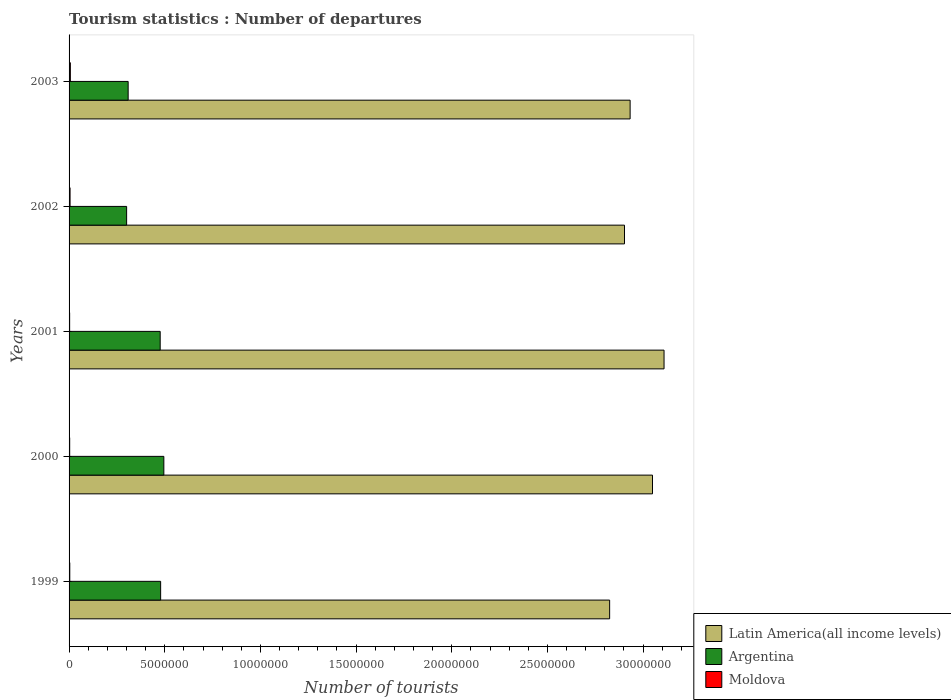Are the number of bars on each tick of the Y-axis equal?
Your answer should be very brief. Yes. How many bars are there on the 2nd tick from the top?
Ensure brevity in your answer.  3. What is the label of the 4th group of bars from the top?
Ensure brevity in your answer.  2000. What is the number of tourist departures in Latin America(all income levels) in 1999?
Give a very brief answer. 2.83e+07. Across all years, what is the maximum number of tourist departures in Moldova?
Ensure brevity in your answer.  6.70e+04. Across all years, what is the minimum number of tourist departures in Moldova?
Your answer should be very brief. 3.00e+04. In which year was the number of tourist departures in Moldova minimum?
Ensure brevity in your answer.  2001. What is the total number of tourist departures in Argentina in the graph?
Make the answer very short. 2.06e+07. What is the difference between the number of tourist departures in Argentina in 2002 and that in 2003?
Your answer should be very brief. -8.00e+04. What is the difference between the number of tourist departures in Argentina in 2000 and the number of tourist departures in Latin America(all income levels) in 2002?
Make the answer very short. -2.41e+07. What is the average number of tourist departures in Argentina per year?
Give a very brief answer. 4.12e+06. In the year 1999, what is the difference between the number of tourist departures in Argentina and number of tourist departures in Moldova?
Give a very brief answer. 4.75e+06. What is the ratio of the number of tourist departures in Argentina in 2001 to that in 2002?
Your answer should be very brief. 1.58. Is the number of tourist departures in Moldova in 1999 less than that in 2002?
Ensure brevity in your answer.  Yes. What is the difference between the highest and the second highest number of tourist departures in Latin America(all income levels)?
Your response must be concise. 6.03e+05. What is the difference between the highest and the lowest number of tourist departures in Moldova?
Ensure brevity in your answer.  3.70e+04. Is the sum of the number of tourist departures in Argentina in 2001 and 2002 greater than the maximum number of tourist departures in Latin America(all income levels) across all years?
Your response must be concise. No. What does the 3rd bar from the top in 2000 represents?
Make the answer very short. Latin America(all income levels). What does the 3rd bar from the bottom in 2001 represents?
Offer a terse response. Moldova. How many bars are there?
Provide a short and direct response. 15. Are all the bars in the graph horizontal?
Offer a very short reply. Yes. Are the values on the major ticks of X-axis written in scientific E-notation?
Offer a very short reply. No. Does the graph contain any zero values?
Keep it short and to the point. No. Does the graph contain grids?
Give a very brief answer. No. Where does the legend appear in the graph?
Offer a terse response. Bottom right. How many legend labels are there?
Make the answer very short. 3. How are the legend labels stacked?
Ensure brevity in your answer.  Vertical. What is the title of the graph?
Offer a very short reply. Tourism statistics : Number of departures. What is the label or title of the X-axis?
Ensure brevity in your answer.  Number of tourists. What is the Number of tourists in Latin America(all income levels) in 1999?
Your answer should be very brief. 2.83e+07. What is the Number of tourists of Argentina in 1999?
Your answer should be very brief. 4.79e+06. What is the Number of tourists in Moldova in 1999?
Your response must be concise. 3.70e+04. What is the Number of tourists of Latin America(all income levels) in 2000?
Give a very brief answer. 3.05e+07. What is the Number of tourists of Argentina in 2000?
Offer a very short reply. 4.95e+06. What is the Number of tourists in Moldova in 2000?
Your answer should be very brief. 3.20e+04. What is the Number of tourists of Latin America(all income levels) in 2001?
Provide a succinct answer. 3.11e+07. What is the Number of tourists of Argentina in 2001?
Provide a succinct answer. 4.76e+06. What is the Number of tourists of Moldova in 2001?
Offer a terse response. 3.00e+04. What is the Number of tourists of Latin America(all income levels) in 2002?
Your response must be concise. 2.90e+07. What is the Number of tourists of Argentina in 2002?
Ensure brevity in your answer.  3.01e+06. What is the Number of tourists of Moldova in 2002?
Your response must be concise. 5.20e+04. What is the Number of tourists of Latin America(all income levels) in 2003?
Keep it short and to the point. 2.93e+07. What is the Number of tourists in Argentina in 2003?
Keep it short and to the point. 3.09e+06. What is the Number of tourists in Moldova in 2003?
Offer a terse response. 6.70e+04. Across all years, what is the maximum Number of tourists in Latin America(all income levels)?
Make the answer very short. 3.11e+07. Across all years, what is the maximum Number of tourists in Argentina?
Your response must be concise. 4.95e+06. Across all years, what is the maximum Number of tourists of Moldova?
Keep it short and to the point. 6.70e+04. Across all years, what is the minimum Number of tourists of Latin America(all income levels)?
Make the answer very short. 2.83e+07. Across all years, what is the minimum Number of tourists of Argentina?
Provide a succinct answer. 3.01e+06. Across all years, what is the minimum Number of tourists in Moldova?
Ensure brevity in your answer.  3.00e+04. What is the total Number of tourists in Latin America(all income levels) in the graph?
Offer a very short reply. 1.48e+08. What is the total Number of tourists in Argentina in the graph?
Give a very brief answer. 2.06e+07. What is the total Number of tourists of Moldova in the graph?
Your answer should be very brief. 2.18e+05. What is the difference between the Number of tourists of Latin America(all income levels) in 1999 and that in 2000?
Your answer should be very brief. -2.24e+06. What is the difference between the Number of tourists of Argentina in 1999 and that in 2000?
Offer a terse response. -1.67e+05. What is the difference between the Number of tourists in Latin America(all income levels) in 1999 and that in 2001?
Make the answer very short. -2.84e+06. What is the difference between the Number of tourists of Argentina in 1999 and that in 2001?
Offer a very short reply. 2.40e+04. What is the difference between the Number of tourists of Moldova in 1999 and that in 2001?
Offer a terse response. 7000. What is the difference between the Number of tourists of Latin America(all income levels) in 1999 and that in 2002?
Your response must be concise. -7.77e+05. What is the difference between the Number of tourists in Argentina in 1999 and that in 2002?
Your answer should be compact. 1.78e+06. What is the difference between the Number of tourists of Moldova in 1999 and that in 2002?
Ensure brevity in your answer.  -1.50e+04. What is the difference between the Number of tourists of Latin America(all income levels) in 1999 and that in 2003?
Provide a short and direct response. -1.07e+06. What is the difference between the Number of tourists of Argentina in 1999 and that in 2003?
Keep it short and to the point. 1.70e+06. What is the difference between the Number of tourists in Moldova in 1999 and that in 2003?
Keep it short and to the point. -3.00e+04. What is the difference between the Number of tourists in Latin America(all income levels) in 2000 and that in 2001?
Offer a very short reply. -6.03e+05. What is the difference between the Number of tourists of Argentina in 2000 and that in 2001?
Offer a terse response. 1.91e+05. What is the difference between the Number of tourists of Latin America(all income levels) in 2000 and that in 2002?
Offer a very short reply. 1.46e+06. What is the difference between the Number of tourists of Argentina in 2000 and that in 2002?
Offer a very short reply. 1.94e+06. What is the difference between the Number of tourists of Latin America(all income levels) in 2000 and that in 2003?
Offer a very short reply. 1.17e+06. What is the difference between the Number of tourists in Argentina in 2000 and that in 2003?
Provide a short and direct response. 1.86e+06. What is the difference between the Number of tourists in Moldova in 2000 and that in 2003?
Your answer should be compact. -3.50e+04. What is the difference between the Number of tourists in Latin America(all income levels) in 2001 and that in 2002?
Offer a very short reply. 2.07e+06. What is the difference between the Number of tourists of Argentina in 2001 and that in 2002?
Ensure brevity in your answer.  1.75e+06. What is the difference between the Number of tourists of Moldova in 2001 and that in 2002?
Offer a terse response. -2.20e+04. What is the difference between the Number of tourists in Latin America(all income levels) in 2001 and that in 2003?
Your answer should be compact. 1.77e+06. What is the difference between the Number of tourists of Argentina in 2001 and that in 2003?
Your answer should be compact. 1.67e+06. What is the difference between the Number of tourists in Moldova in 2001 and that in 2003?
Keep it short and to the point. -3.70e+04. What is the difference between the Number of tourists in Latin America(all income levels) in 2002 and that in 2003?
Your answer should be compact. -2.94e+05. What is the difference between the Number of tourists of Moldova in 2002 and that in 2003?
Your answer should be very brief. -1.50e+04. What is the difference between the Number of tourists in Latin America(all income levels) in 1999 and the Number of tourists in Argentina in 2000?
Ensure brevity in your answer.  2.33e+07. What is the difference between the Number of tourists of Latin America(all income levels) in 1999 and the Number of tourists of Moldova in 2000?
Give a very brief answer. 2.82e+07. What is the difference between the Number of tourists of Argentina in 1999 and the Number of tourists of Moldova in 2000?
Provide a succinct answer. 4.75e+06. What is the difference between the Number of tourists of Latin America(all income levels) in 1999 and the Number of tourists of Argentina in 2001?
Offer a very short reply. 2.35e+07. What is the difference between the Number of tourists in Latin America(all income levels) in 1999 and the Number of tourists in Moldova in 2001?
Your answer should be compact. 2.82e+07. What is the difference between the Number of tourists of Argentina in 1999 and the Number of tourists of Moldova in 2001?
Provide a short and direct response. 4.76e+06. What is the difference between the Number of tourists in Latin America(all income levels) in 1999 and the Number of tourists in Argentina in 2002?
Offer a terse response. 2.52e+07. What is the difference between the Number of tourists of Latin America(all income levels) in 1999 and the Number of tourists of Moldova in 2002?
Keep it short and to the point. 2.82e+07. What is the difference between the Number of tourists in Argentina in 1999 and the Number of tourists in Moldova in 2002?
Provide a succinct answer. 4.73e+06. What is the difference between the Number of tourists in Latin America(all income levels) in 1999 and the Number of tourists in Argentina in 2003?
Your response must be concise. 2.52e+07. What is the difference between the Number of tourists in Latin America(all income levels) in 1999 and the Number of tourists in Moldova in 2003?
Make the answer very short. 2.82e+07. What is the difference between the Number of tourists in Argentina in 1999 and the Number of tourists in Moldova in 2003?
Your answer should be very brief. 4.72e+06. What is the difference between the Number of tourists of Latin America(all income levels) in 2000 and the Number of tourists of Argentina in 2001?
Make the answer very short. 2.57e+07. What is the difference between the Number of tourists in Latin America(all income levels) in 2000 and the Number of tourists in Moldova in 2001?
Make the answer very short. 3.05e+07. What is the difference between the Number of tourists of Argentina in 2000 and the Number of tourists of Moldova in 2001?
Your response must be concise. 4.92e+06. What is the difference between the Number of tourists of Latin America(all income levels) in 2000 and the Number of tourists of Argentina in 2002?
Offer a very short reply. 2.75e+07. What is the difference between the Number of tourists of Latin America(all income levels) in 2000 and the Number of tourists of Moldova in 2002?
Ensure brevity in your answer.  3.04e+07. What is the difference between the Number of tourists in Argentina in 2000 and the Number of tourists in Moldova in 2002?
Provide a short and direct response. 4.90e+06. What is the difference between the Number of tourists in Latin America(all income levels) in 2000 and the Number of tourists in Argentina in 2003?
Ensure brevity in your answer.  2.74e+07. What is the difference between the Number of tourists of Latin America(all income levels) in 2000 and the Number of tourists of Moldova in 2003?
Provide a short and direct response. 3.04e+07. What is the difference between the Number of tourists of Argentina in 2000 and the Number of tourists of Moldova in 2003?
Make the answer very short. 4.89e+06. What is the difference between the Number of tourists in Latin America(all income levels) in 2001 and the Number of tourists in Argentina in 2002?
Your answer should be compact. 2.81e+07. What is the difference between the Number of tourists of Latin America(all income levels) in 2001 and the Number of tourists of Moldova in 2002?
Your answer should be very brief. 3.10e+07. What is the difference between the Number of tourists in Argentina in 2001 and the Number of tourists in Moldova in 2002?
Give a very brief answer. 4.71e+06. What is the difference between the Number of tourists of Latin America(all income levels) in 2001 and the Number of tourists of Argentina in 2003?
Offer a terse response. 2.80e+07. What is the difference between the Number of tourists of Latin America(all income levels) in 2001 and the Number of tourists of Moldova in 2003?
Your answer should be very brief. 3.10e+07. What is the difference between the Number of tourists of Argentina in 2001 and the Number of tourists of Moldova in 2003?
Offer a very short reply. 4.70e+06. What is the difference between the Number of tourists of Latin America(all income levels) in 2002 and the Number of tourists of Argentina in 2003?
Your answer should be very brief. 2.59e+07. What is the difference between the Number of tourists of Latin America(all income levels) in 2002 and the Number of tourists of Moldova in 2003?
Provide a short and direct response. 2.90e+07. What is the difference between the Number of tourists in Argentina in 2002 and the Number of tourists in Moldova in 2003?
Offer a terse response. 2.94e+06. What is the average Number of tourists of Latin America(all income levels) per year?
Offer a very short reply. 2.96e+07. What is the average Number of tourists of Argentina per year?
Your response must be concise. 4.12e+06. What is the average Number of tourists in Moldova per year?
Your answer should be very brief. 4.36e+04. In the year 1999, what is the difference between the Number of tourists in Latin America(all income levels) and Number of tourists in Argentina?
Your answer should be very brief. 2.35e+07. In the year 1999, what is the difference between the Number of tourists in Latin America(all income levels) and Number of tourists in Moldova?
Give a very brief answer. 2.82e+07. In the year 1999, what is the difference between the Number of tourists of Argentina and Number of tourists of Moldova?
Offer a terse response. 4.75e+06. In the year 2000, what is the difference between the Number of tourists of Latin America(all income levels) and Number of tourists of Argentina?
Keep it short and to the point. 2.55e+07. In the year 2000, what is the difference between the Number of tourists of Latin America(all income levels) and Number of tourists of Moldova?
Give a very brief answer. 3.05e+07. In the year 2000, what is the difference between the Number of tourists in Argentina and Number of tourists in Moldova?
Your answer should be compact. 4.92e+06. In the year 2001, what is the difference between the Number of tourists of Latin America(all income levels) and Number of tourists of Argentina?
Offer a terse response. 2.63e+07. In the year 2001, what is the difference between the Number of tourists in Latin America(all income levels) and Number of tourists in Moldova?
Keep it short and to the point. 3.11e+07. In the year 2001, what is the difference between the Number of tourists of Argentina and Number of tourists of Moldova?
Provide a short and direct response. 4.73e+06. In the year 2002, what is the difference between the Number of tourists in Latin America(all income levels) and Number of tourists in Argentina?
Your response must be concise. 2.60e+07. In the year 2002, what is the difference between the Number of tourists in Latin America(all income levels) and Number of tourists in Moldova?
Keep it short and to the point. 2.90e+07. In the year 2002, what is the difference between the Number of tourists of Argentina and Number of tourists of Moldova?
Your response must be concise. 2.96e+06. In the year 2003, what is the difference between the Number of tourists of Latin America(all income levels) and Number of tourists of Argentina?
Offer a terse response. 2.62e+07. In the year 2003, what is the difference between the Number of tourists in Latin America(all income levels) and Number of tourists in Moldova?
Offer a very short reply. 2.93e+07. In the year 2003, what is the difference between the Number of tourists of Argentina and Number of tourists of Moldova?
Offer a terse response. 3.02e+06. What is the ratio of the Number of tourists in Latin America(all income levels) in 1999 to that in 2000?
Make the answer very short. 0.93. What is the ratio of the Number of tourists in Argentina in 1999 to that in 2000?
Your response must be concise. 0.97. What is the ratio of the Number of tourists in Moldova in 1999 to that in 2000?
Keep it short and to the point. 1.16. What is the ratio of the Number of tourists in Latin America(all income levels) in 1999 to that in 2001?
Offer a terse response. 0.91. What is the ratio of the Number of tourists in Moldova in 1999 to that in 2001?
Provide a short and direct response. 1.23. What is the ratio of the Number of tourists in Latin America(all income levels) in 1999 to that in 2002?
Give a very brief answer. 0.97. What is the ratio of the Number of tourists of Argentina in 1999 to that in 2002?
Give a very brief answer. 1.59. What is the ratio of the Number of tourists of Moldova in 1999 to that in 2002?
Keep it short and to the point. 0.71. What is the ratio of the Number of tourists of Latin America(all income levels) in 1999 to that in 2003?
Offer a terse response. 0.96. What is the ratio of the Number of tourists of Argentina in 1999 to that in 2003?
Your answer should be compact. 1.55. What is the ratio of the Number of tourists in Moldova in 1999 to that in 2003?
Your response must be concise. 0.55. What is the ratio of the Number of tourists of Latin America(all income levels) in 2000 to that in 2001?
Keep it short and to the point. 0.98. What is the ratio of the Number of tourists of Argentina in 2000 to that in 2001?
Keep it short and to the point. 1.04. What is the ratio of the Number of tourists of Moldova in 2000 to that in 2001?
Your answer should be compact. 1.07. What is the ratio of the Number of tourists in Latin America(all income levels) in 2000 to that in 2002?
Offer a very short reply. 1.05. What is the ratio of the Number of tourists of Argentina in 2000 to that in 2002?
Offer a terse response. 1.65. What is the ratio of the Number of tourists of Moldova in 2000 to that in 2002?
Give a very brief answer. 0.62. What is the ratio of the Number of tourists of Latin America(all income levels) in 2000 to that in 2003?
Provide a short and direct response. 1.04. What is the ratio of the Number of tourists in Argentina in 2000 to that in 2003?
Make the answer very short. 1.6. What is the ratio of the Number of tourists of Moldova in 2000 to that in 2003?
Offer a very short reply. 0.48. What is the ratio of the Number of tourists of Latin America(all income levels) in 2001 to that in 2002?
Offer a very short reply. 1.07. What is the ratio of the Number of tourists of Argentina in 2001 to that in 2002?
Provide a succinct answer. 1.58. What is the ratio of the Number of tourists of Moldova in 2001 to that in 2002?
Offer a very short reply. 0.58. What is the ratio of the Number of tourists of Latin America(all income levels) in 2001 to that in 2003?
Your answer should be compact. 1.06. What is the ratio of the Number of tourists of Argentina in 2001 to that in 2003?
Your response must be concise. 1.54. What is the ratio of the Number of tourists of Moldova in 2001 to that in 2003?
Make the answer very short. 0.45. What is the ratio of the Number of tourists of Latin America(all income levels) in 2002 to that in 2003?
Your answer should be compact. 0.99. What is the ratio of the Number of tourists in Argentina in 2002 to that in 2003?
Offer a very short reply. 0.97. What is the ratio of the Number of tourists in Moldova in 2002 to that in 2003?
Your answer should be compact. 0.78. What is the difference between the highest and the second highest Number of tourists of Latin America(all income levels)?
Ensure brevity in your answer.  6.03e+05. What is the difference between the highest and the second highest Number of tourists of Argentina?
Your response must be concise. 1.67e+05. What is the difference between the highest and the second highest Number of tourists of Moldova?
Offer a very short reply. 1.50e+04. What is the difference between the highest and the lowest Number of tourists in Latin America(all income levels)?
Offer a terse response. 2.84e+06. What is the difference between the highest and the lowest Number of tourists of Argentina?
Offer a very short reply. 1.94e+06. What is the difference between the highest and the lowest Number of tourists of Moldova?
Your answer should be very brief. 3.70e+04. 